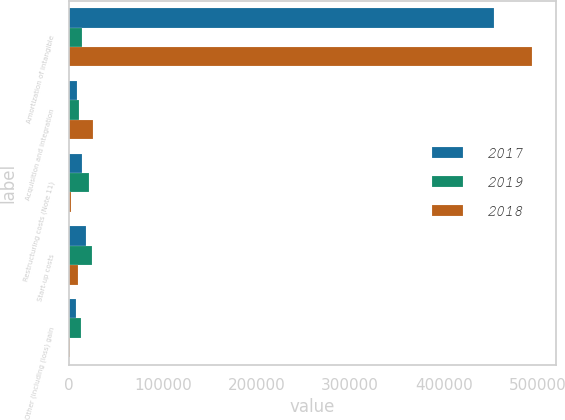Convert chart. <chart><loc_0><loc_0><loc_500><loc_500><stacked_bar_chart><ecel><fcel>Amortization of intangible<fcel>Acquisition and integration<fcel>Restructuring costs (Note 11)<fcel>Start-up costs<fcel>Other (including (loss) gain<nl><fcel>2017<fcel>453515<fcel>8522<fcel>13467<fcel>18035<fcel>7463<nl><fcel>2019<fcel>13360<fcel>10561<fcel>21406<fcel>24271<fcel>13253<nl><fcel>2018<fcel>494387<fcel>25391<fcel>1696<fcel>9694<fcel>1532<nl></chart> 